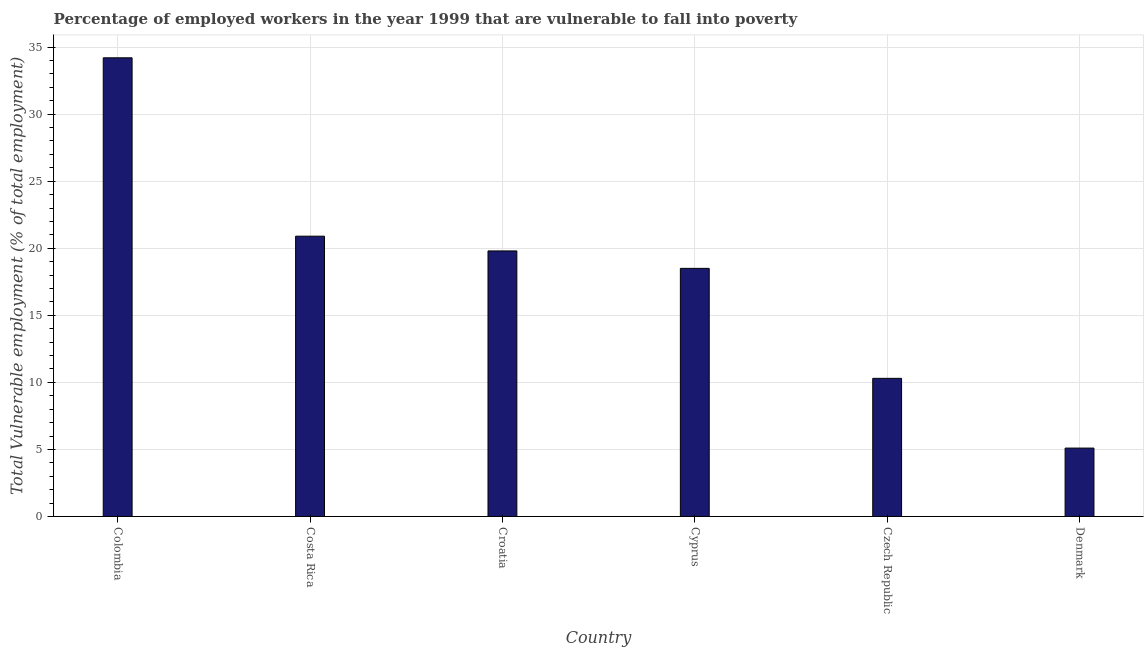Does the graph contain grids?
Your answer should be very brief. Yes. What is the title of the graph?
Offer a very short reply. Percentage of employed workers in the year 1999 that are vulnerable to fall into poverty. What is the label or title of the Y-axis?
Provide a succinct answer. Total Vulnerable employment (% of total employment). What is the total vulnerable employment in Denmark?
Provide a succinct answer. 5.1. Across all countries, what is the maximum total vulnerable employment?
Keep it short and to the point. 34.2. Across all countries, what is the minimum total vulnerable employment?
Make the answer very short. 5.1. In which country was the total vulnerable employment maximum?
Make the answer very short. Colombia. In which country was the total vulnerable employment minimum?
Your answer should be compact. Denmark. What is the sum of the total vulnerable employment?
Offer a terse response. 108.8. What is the average total vulnerable employment per country?
Keep it short and to the point. 18.13. What is the median total vulnerable employment?
Your answer should be compact. 19.15. In how many countries, is the total vulnerable employment greater than 27 %?
Offer a very short reply. 1. What is the ratio of the total vulnerable employment in Colombia to that in Czech Republic?
Your answer should be very brief. 3.32. Is the total vulnerable employment in Costa Rica less than that in Denmark?
Your response must be concise. No. Is the difference between the total vulnerable employment in Costa Rica and Cyprus greater than the difference between any two countries?
Your answer should be compact. No. What is the difference between the highest and the second highest total vulnerable employment?
Your answer should be very brief. 13.3. What is the difference between the highest and the lowest total vulnerable employment?
Give a very brief answer. 29.1. In how many countries, is the total vulnerable employment greater than the average total vulnerable employment taken over all countries?
Provide a succinct answer. 4. How many bars are there?
Provide a succinct answer. 6. How many countries are there in the graph?
Ensure brevity in your answer.  6. What is the difference between two consecutive major ticks on the Y-axis?
Make the answer very short. 5. Are the values on the major ticks of Y-axis written in scientific E-notation?
Ensure brevity in your answer.  No. What is the Total Vulnerable employment (% of total employment) of Colombia?
Your answer should be compact. 34.2. What is the Total Vulnerable employment (% of total employment) in Costa Rica?
Make the answer very short. 20.9. What is the Total Vulnerable employment (% of total employment) in Croatia?
Make the answer very short. 19.8. What is the Total Vulnerable employment (% of total employment) in Cyprus?
Provide a succinct answer. 18.5. What is the Total Vulnerable employment (% of total employment) in Czech Republic?
Your answer should be very brief. 10.3. What is the Total Vulnerable employment (% of total employment) in Denmark?
Your answer should be very brief. 5.1. What is the difference between the Total Vulnerable employment (% of total employment) in Colombia and Costa Rica?
Your response must be concise. 13.3. What is the difference between the Total Vulnerable employment (% of total employment) in Colombia and Czech Republic?
Keep it short and to the point. 23.9. What is the difference between the Total Vulnerable employment (% of total employment) in Colombia and Denmark?
Provide a short and direct response. 29.1. What is the difference between the Total Vulnerable employment (% of total employment) in Costa Rica and Cyprus?
Provide a succinct answer. 2.4. What is the difference between the Total Vulnerable employment (% of total employment) in Croatia and Cyprus?
Your answer should be compact. 1.3. What is the difference between the Total Vulnerable employment (% of total employment) in Croatia and Denmark?
Give a very brief answer. 14.7. What is the difference between the Total Vulnerable employment (% of total employment) in Cyprus and Czech Republic?
Your answer should be very brief. 8.2. What is the difference between the Total Vulnerable employment (% of total employment) in Cyprus and Denmark?
Provide a short and direct response. 13.4. What is the ratio of the Total Vulnerable employment (% of total employment) in Colombia to that in Costa Rica?
Your answer should be very brief. 1.64. What is the ratio of the Total Vulnerable employment (% of total employment) in Colombia to that in Croatia?
Your answer should be very brief. 1.73. What is the ratio of the Total Vulnerable employment (% of total employment) in Colombia to that in Cyprus?
Offer a terse response. 1.85. What is the ratio of the Total Vulnerable employment (% of total employment) in Colombia to that in Czech Republic?
Your answer should be compact. 3.32. What is the ratio of the Total Vulnerable employment (% of total employment) in Colombia to that in Denmark?
Ensure brevity in your answer.  6.71. What is the ratio of the Total Vulnerable employment (% of total employment) in Costa Rica to that in Croatia?
Keep it short and to the point. 1.06. What is the ratio of the Total Vulnerable employment (% of total employment) in Costa Rica to that in Cyprus?
Provide a succinct answer. 1.13. What is the ratio of the Total Vulnerable employment (% of total employment) in Costa Rica to that in Czech Republic?
Provide a short and direct response. 2.03. What is the ratio of the Total Vulnerable employment (% of total employment) in Costa Rica to that in Denmark?
Your answer should be very brief. 4.1. What is the ratio of the Total Vulnerable employment (% of total employment) in Croatia to that in Cyprus?
Your answer should be very brief. 1.07. What is the ratio of the Total Vulnerable employment (% of total employment) in Croatia to that in Czech Republic?
Ensure brevity in your answer.  1.92. What is the ratio of the Total Vulnerable employment (% of total employment) in Croatia to that in Denmark?
Provide a short and direct response. 3.88. What is the ratio of the Total Vulnerable employment (% of total employment) in Cyprus to that in Czech Republic?
Offer a very short reply. 1.8. What is the ratio of the Total Vulnerable employment (% of total employment) in Cyprus to that in Denmark?
Your answer should be compact. 3.63. What is the ratio of the Total Vulnerable employment (% of total employment) in Czech Republic to that in Denmark?
Provide a short and direct response. 2.02. 